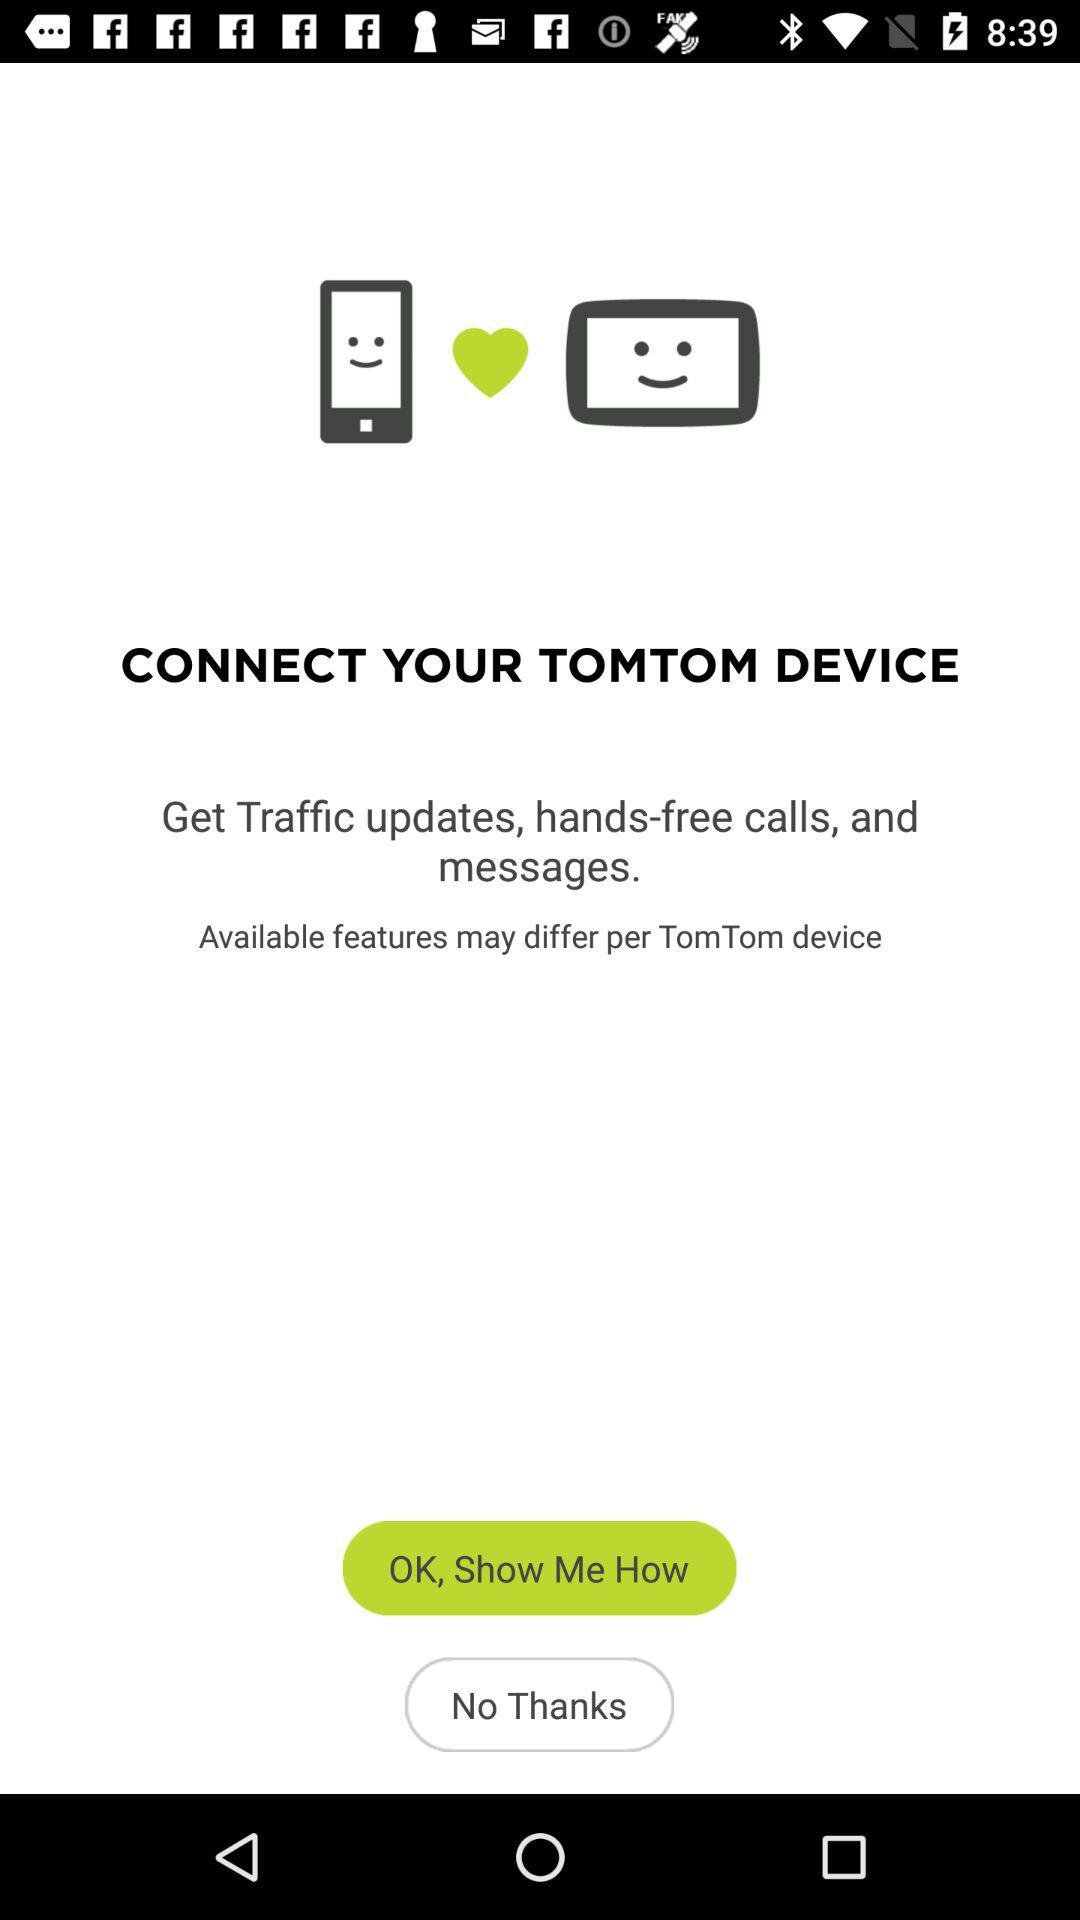What is the device name? The device name is "TOMTOM". 